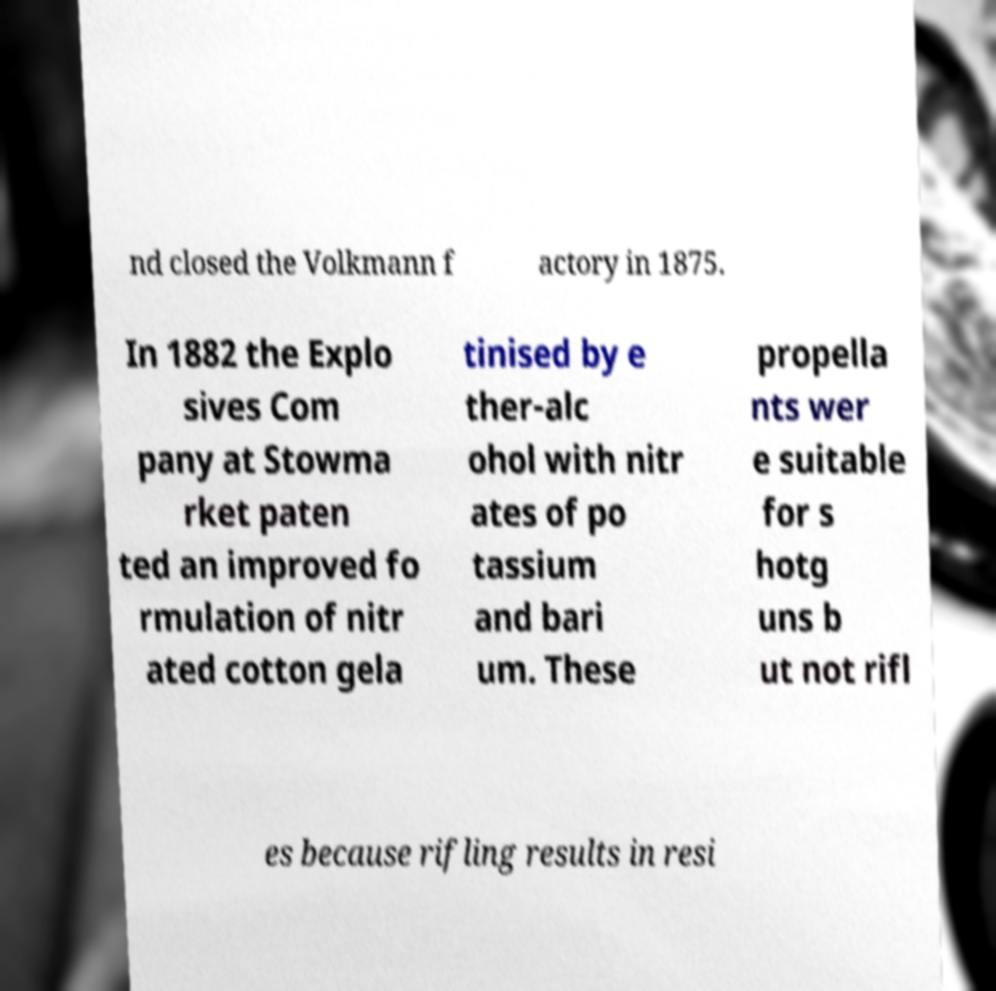Could you assist in decoding the text presented in this image and type it out clearly? nd closed the Volkmann f actory in 1875. In 1882 the Explo sives Com pany at Stowma rket paten ted an improved fo rmulation of nitr ated cotton gela tinised by e ther-alc ohol with nitr ates of po tassium and bari um. These propella nts wer e suitable for s hotg uns b ut not rifl es because rifling results in resi 